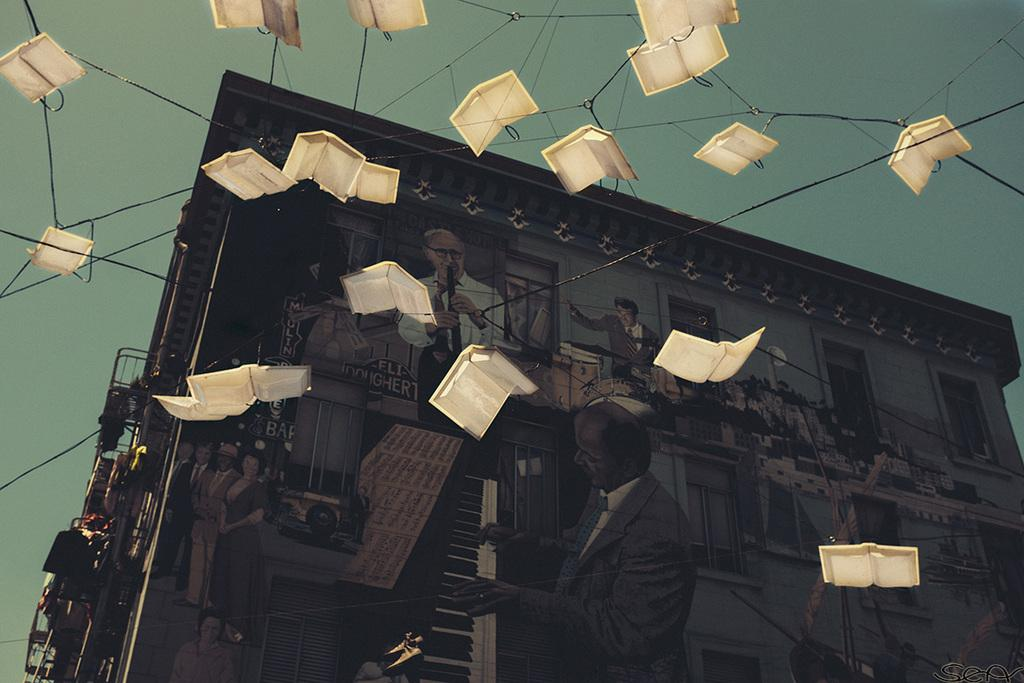What is the main structure visible in the image? There is a building in the image. Can you describe any additional features or objects in the image? Yes, there are decorative items hanging in the air with strings attached to them in the image. What type of reward is being given out at the meeting in the image? There is no meeting or reward present in the image; it only features a building and decorative items hanging with strings. 